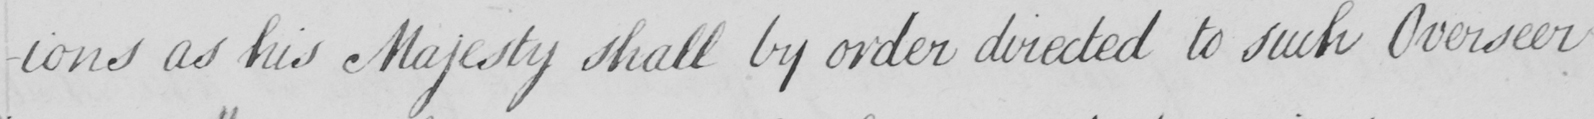Transcribe the text shown in this historical manuscript line. -ons as his Majesty shall by order directed to such Overseer 